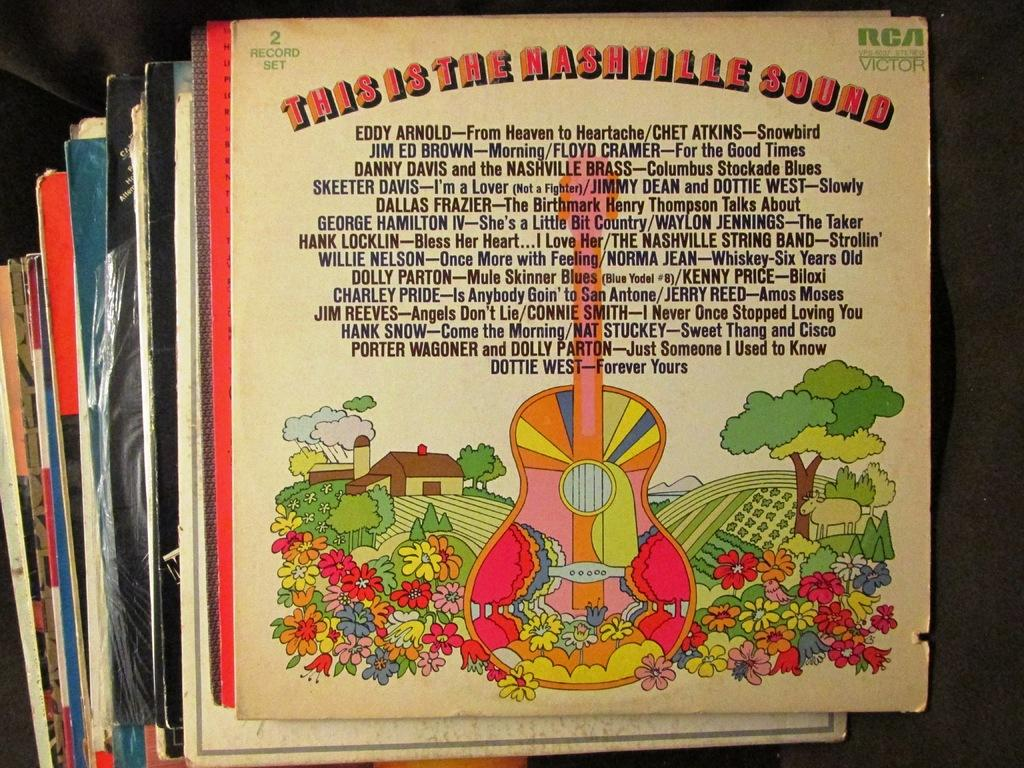<image>
Summarize the visual content of the image. A bunch of old vinyl records are stacked on top of each other with Nashville one being on very top. 